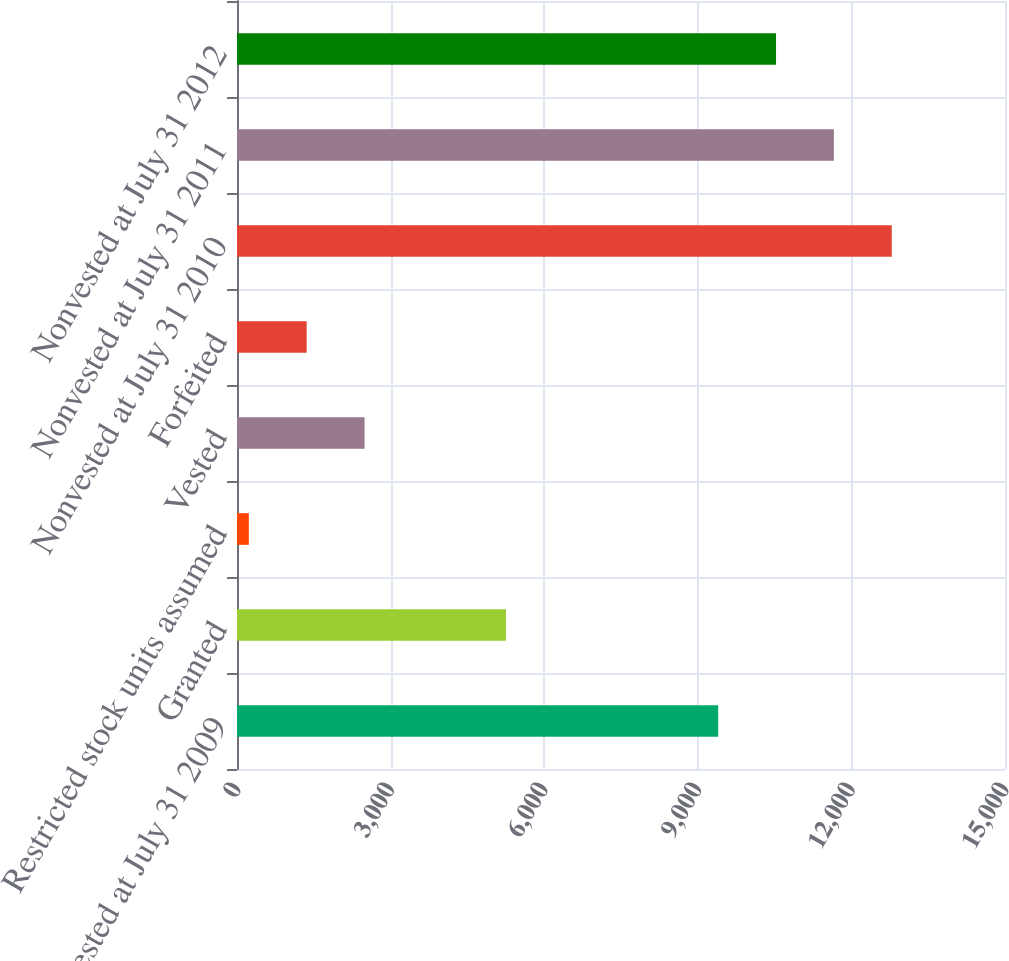Convert chart. <chart><loc_0><loc_0><loc_500><loc_500><bar_chart><fcel>Nonvested at July 31 2009<fcel>Granted<fcel>Restricted stock units assumed<fcel>Vested<fcel>Forfeited<fcel>Nonvested at July 31 2010<fcel>Nonvested at July 31 2011<fcel>Nonvested at July 31 2012<nl><fcel>9398<fcel>5253<fcel>231<fcel>2491<fcel>1361<fcel>12788<fcel>11658<fcel>10528<nl></chart> 